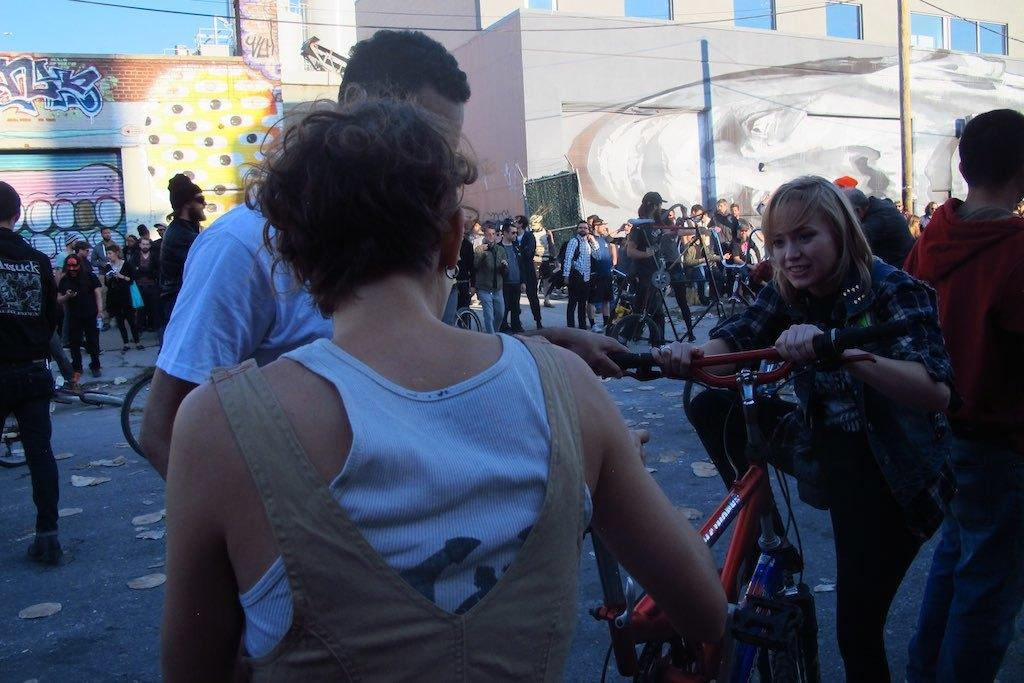Where was the image taken? The image was taken on a road. What is happening on the road in the image? Many people are standing on the road, and two people are catching a bicycle. What can be seen on the walls in the background of the image? There is graffiti on the walls in the background. Where is the sofa located in the image? There is no sofa present in the image. What type of nail is being used by the people in the image? There is no nail being used by the people in the image; they are catching a bicycle. 